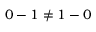<formula> <loc_0><loc_0><loc_500><loc_500>0 - 1 \neq 1 - 0</formula> 